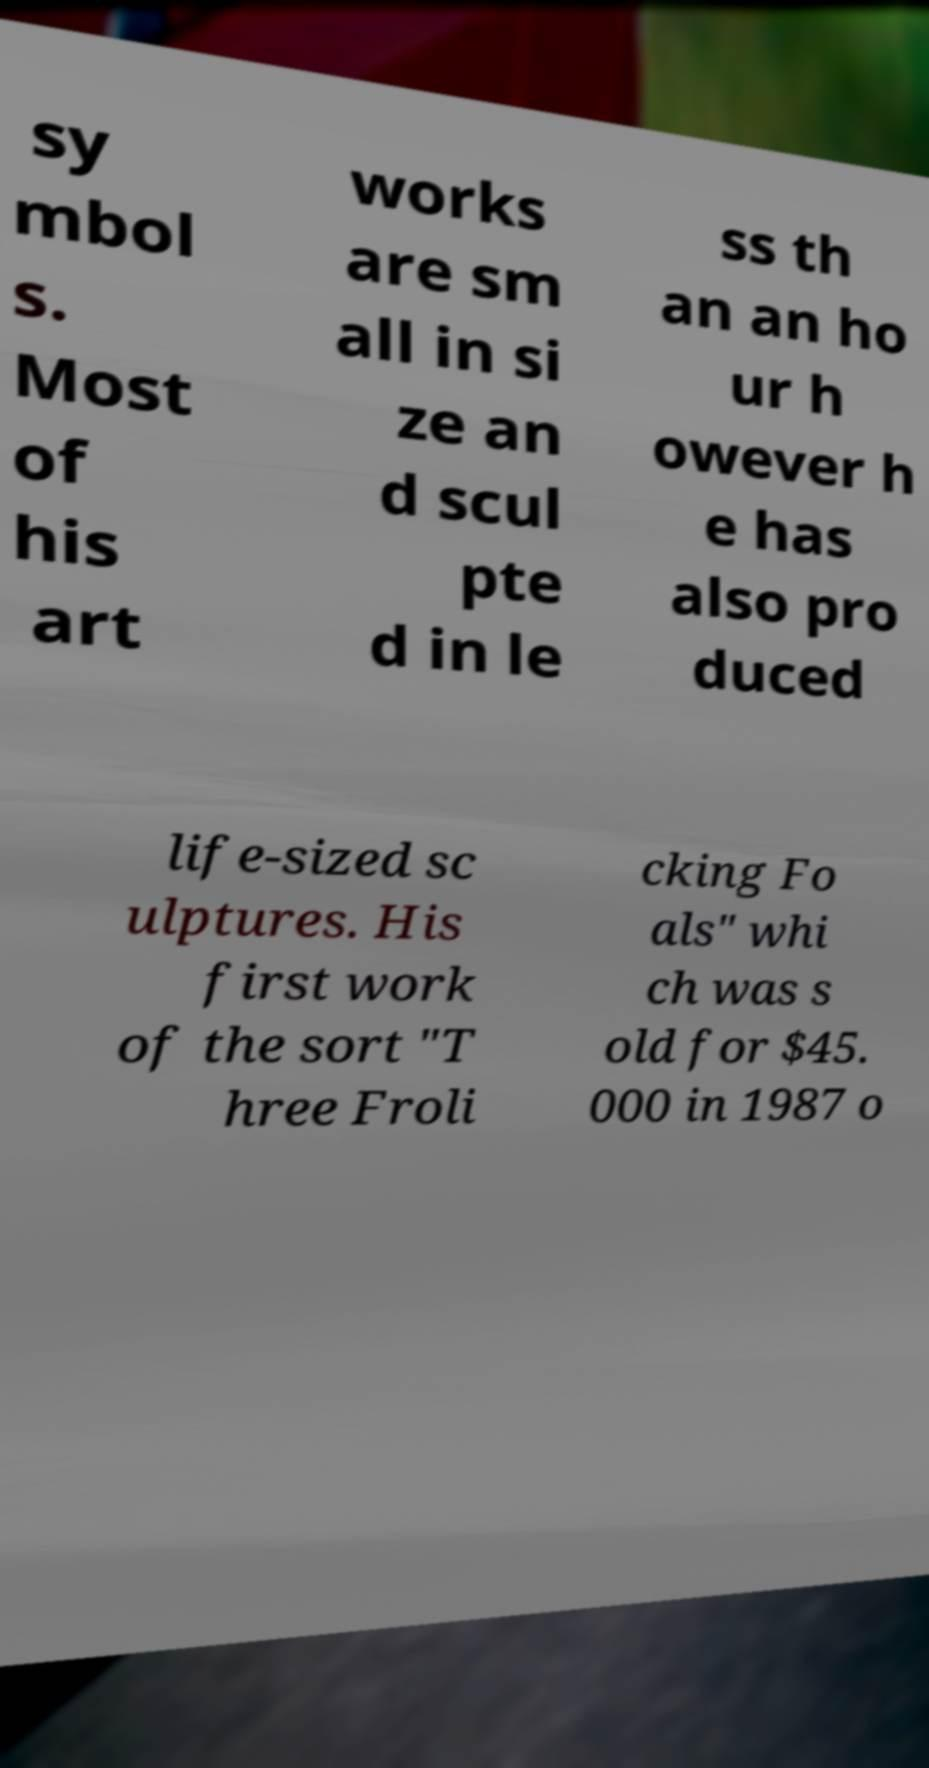What messages or text are displayed in this image? I need them in a readable, typed format. sy mbol s. Most of his art works are sm all in si ze an d scul pte d in le ss th an an ho ur h owever h e has also pro duced life-sized sc ulptures. His first work of the sort "T hree Froli cking Fo als" whi ch was s old for $45. 000 in 1987 o 